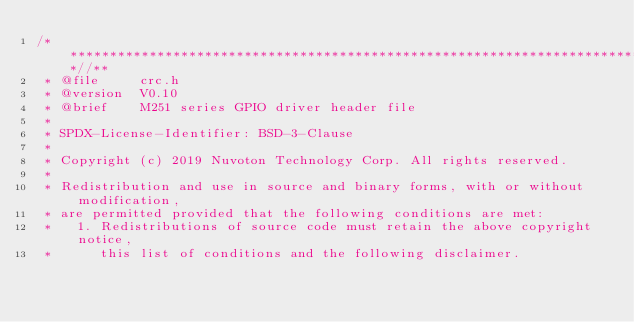Convert code to text. <code><loc_0><loc_0><loc_500><loc_500><_C_>/**************************************************************************//**
 * @file     crc.h
 * @version  V0.10
 * @brief    M251 series GPIO driver header file
 *
 * SPDX-License-Identifier: BSD-3-Clause
 *
 * Copyright (c) 2019 Nuvoton Technology Corp. All rights reserved.
 * 
 * Redistribution and use in source and binary forms, with or without modification,
 * are permitted provided that the following conditions are met:
 *   1. Redistributions of source code must retain the above copyright notice,
 *      this list of conditions and the following disclaimer.</code> 